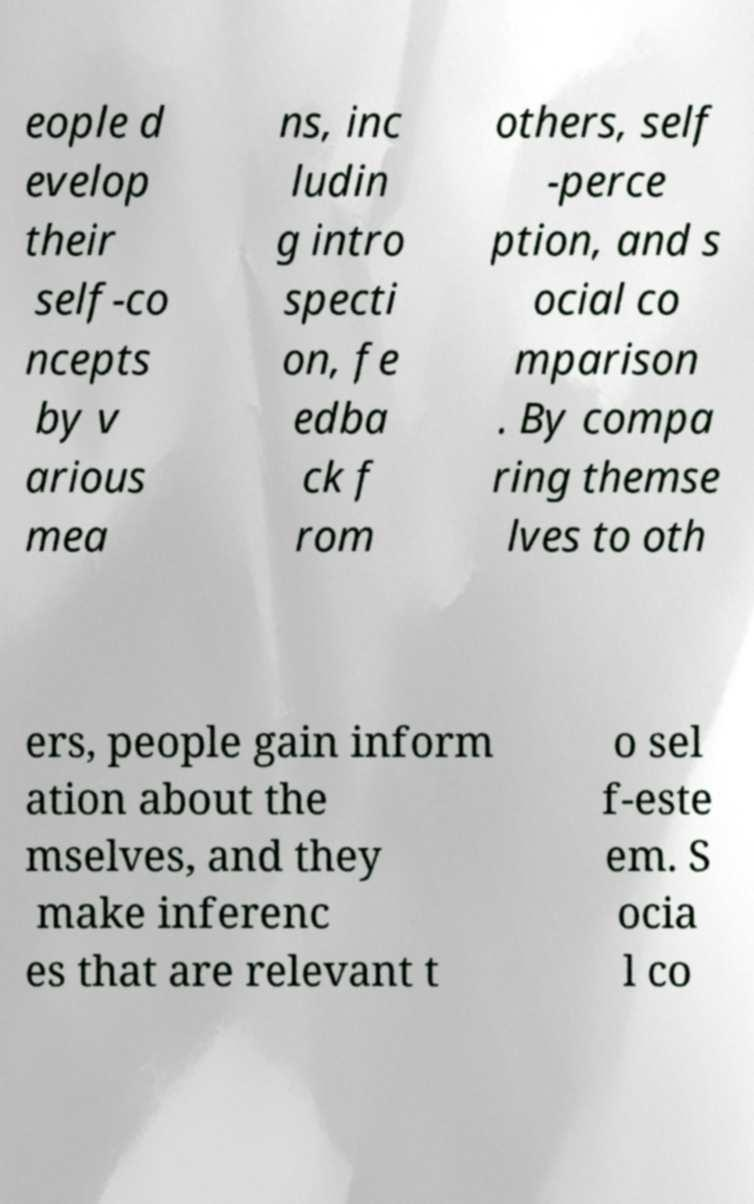Can you accurately transcribe the text from the provided image for me? eople d evelop their self-co ncepts by v arious mea ns, inc ludin g intro specti on, fe edba ck f rom others, self -perce ption, and s ocial co mparison . By compa ring themse lves to oth ers, people gain inform ation about the mselves, and they make inferenc es that are relevant t o sel f-este em. S ocia l co 